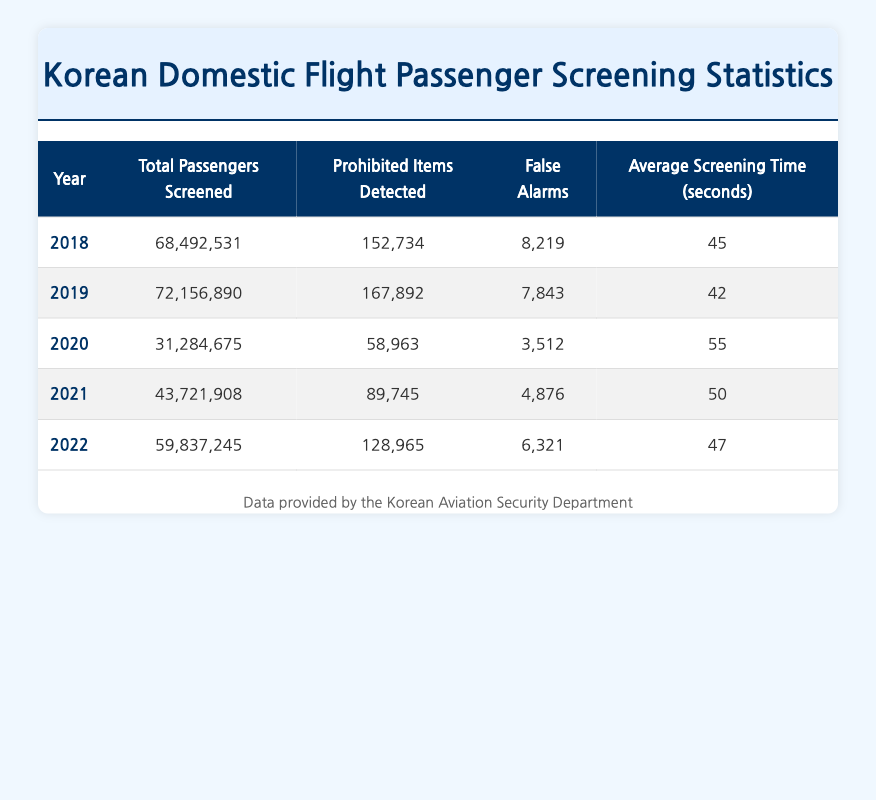What was the total number of passengers screened in 2019? The table shows that in 2019, the total number of passengers screened was 72,156,890.
Answer: 72,156,890 In which year were the most prohibited items detected? By comparing the "Prohibited Items Detected" column for each year, it's clear that the highest number, 167,892, occurred in 2019.
Answer: 2019 What is the average screening time for the years 2018, 2021, and 2022? To find the average screening time for these years, we sum the times: (45 + 50 + 47) = 142 seconds. Dividing by 3 gives us an average of 142/3 = 47.33 seconds, which can be rounded to 47 seconds.
Answer: 47 seconds Did the total number of passengers screened increase from 2020 to 2021? The total passengers screened in 2020 was 31,284,675, and in 2021 it was 43,721,908. Since 43,721,908 is greater than 31,284,675, it confirms that the number increased.
Answer: Yes How many false alarms were there in 2022 compared to 2018? In 2022, there were 6,321 false alarms, whereas in 2018, there were 8,219. Since 6,321 is less than 8,219, it indicates a decrease in false alarms from 2018 to 2022.
Answer: Yes What was the difference in average screening times between 2019 and 2020? The average screening time in 2019 was 42 seconds, and in 2020 it was 55 seconds. The difference is 55 - 42 = 13 seconds.
Answer: 13 seconds Which year had the least number of prohibited items detected? By examining the "Prohibited Items Detected" column, 2020 had the least with 58,963 prohibited items.
Answer: 2020 What was the trend in total passengers screened from 2018 to 2022? The total passengers screened increased from 68,492,531 in 2018 to 72,156,890 in 2019, then decreased to 31,284,675 in 2020, increased to 43,721,908 in 2021, and finally rose to 59,837,245 in 2022. Overall, the trend is an increase after the dip in 2020.
Answer: Increasing after a decline in 2020 